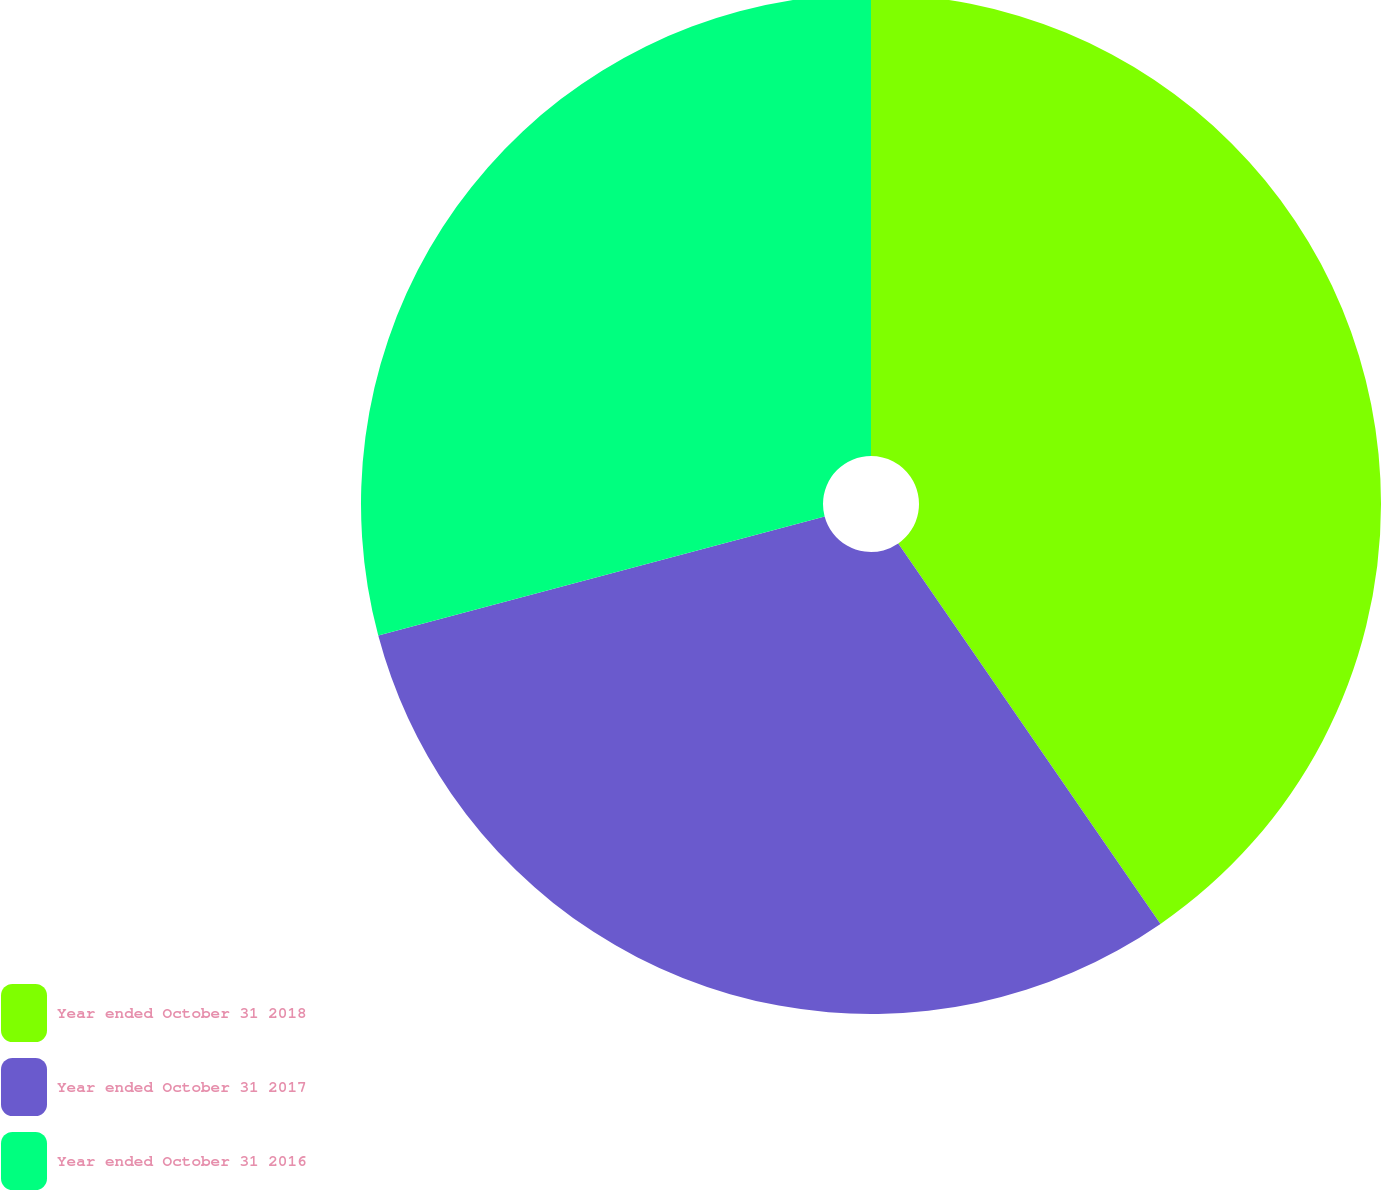<chart> <loc_0><loc_0><loc_500><loc_500><pie_chart><fcel>Year ended October 31 2018<fcel>Year ended October 31 2017<fcel>Year ended October 31 2016<nl><fcel>40.39%<fcel>30.45%<fcel>29.15%<nl></chart> 